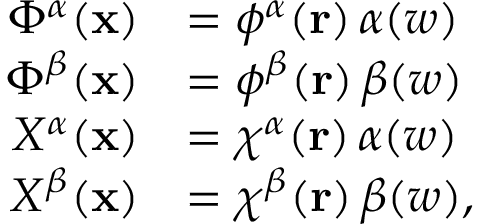<formula> <loc_0><loc_0><loc_500><loc_500>\begin{array} { r l } { \Phi ^ { \alpha } ( x ) } & { = \phi ^ { \alpha } ( r ) \, \alpha ( w ) } \\ { \Phi ^ { \beta } ( x ) } & { = \phi ^ { \beta } ( r ) \, \beta ( w ) } \\ { X ^ { \alpha } ( x ) } & { = \chi ^ { \alpha } ( r ) \, \alpha ( w ) } \\ { X ^ { \beta } ( x ) } & { = \chi ^ { \beta } ( r ) \, \beta ( w ) , } \end{array}</formula> 